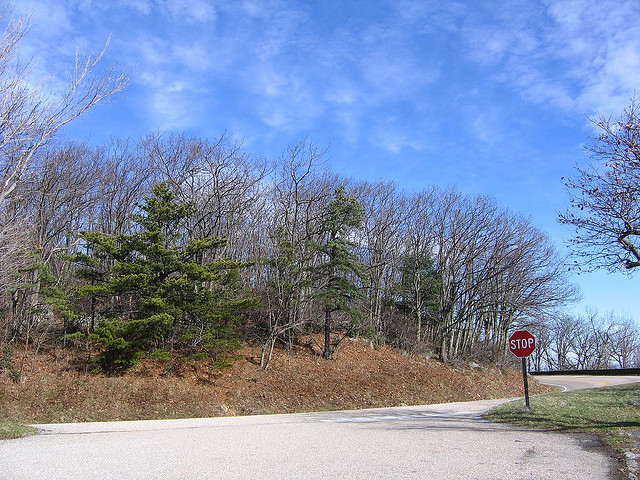How many trees are there? The image shows numerous trees, primarily deciduous, lining the hillside along the road. 